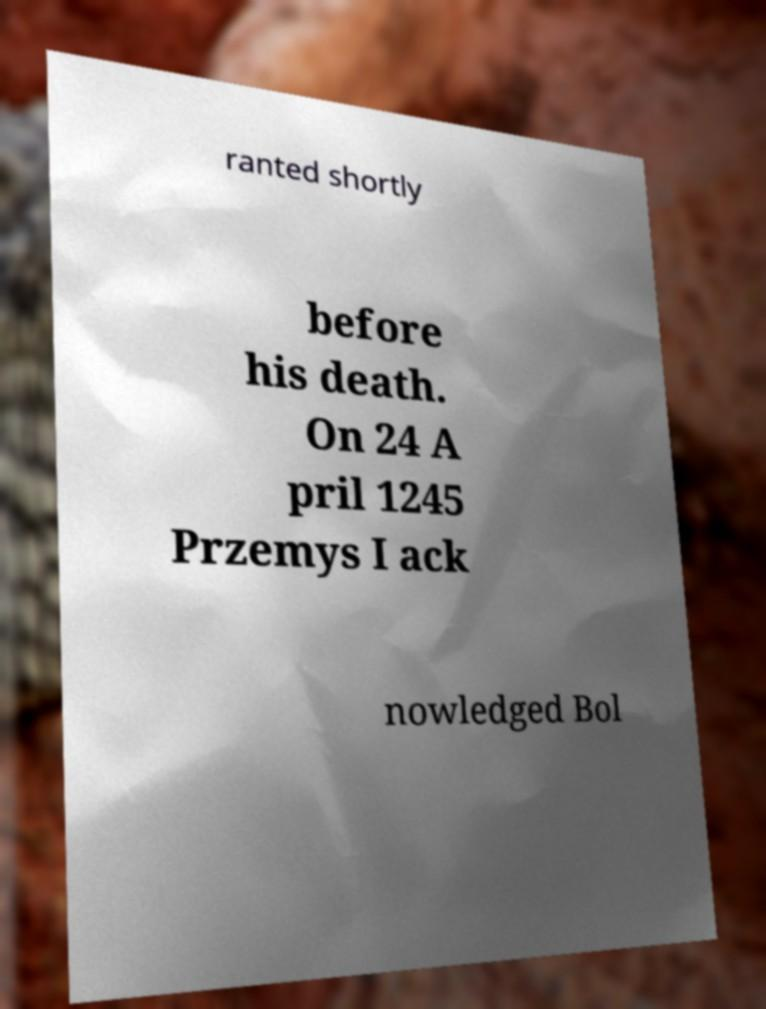Can you read and provide the text displayed in the image?This photo seems to have some interesting text. Can you extract and type it out for me? ranted shortly before his death. On 24 A pril 1245 Przemys I ack nowledged Bol 